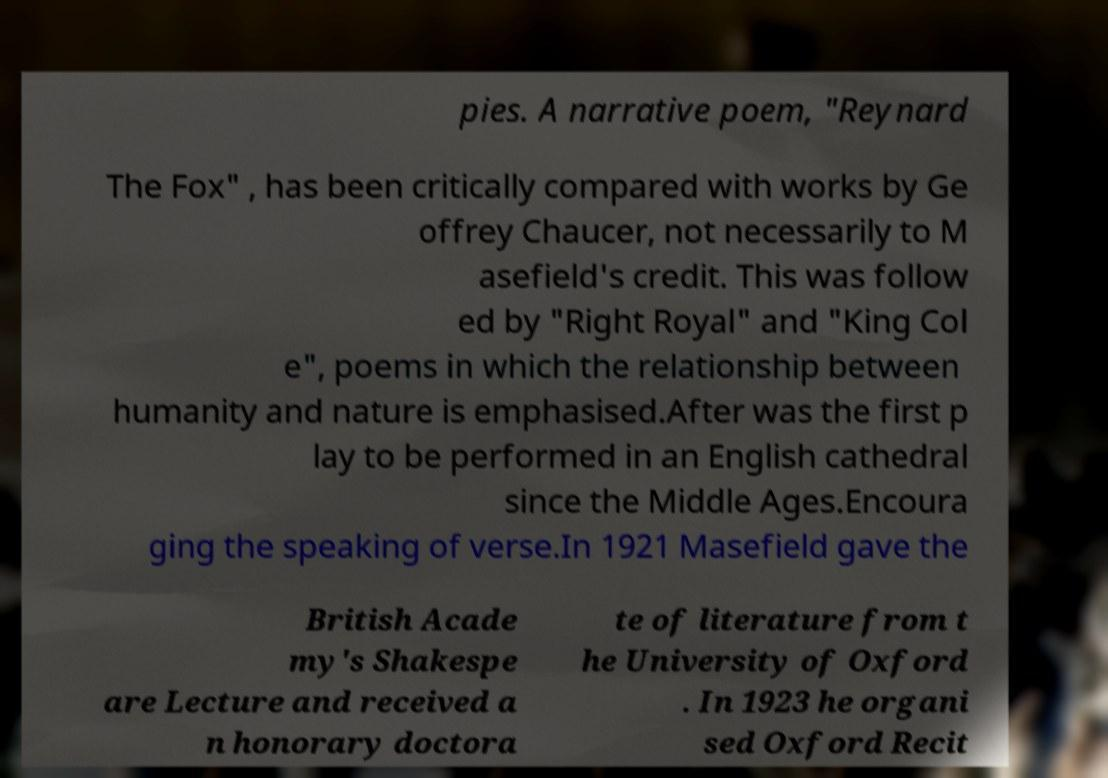Can you read and provide the text displayed in the image?This photo seems to have some interesting text. Can you extract and type it out for me? pies. A narrative poem, "Reynard The Fox" , has been critically compared with works by Ge offrey Chaucer, not necessarily to M asefield's credit. This was follow ed by "Right Royal" and "King Col e", poems in which the relationship between humanity and nature is emphasised.After was the first p lay to be performed in an English cathedral since the Middle Ages.Encoura ging the speaking of verse.In 1921 Masefield gave the British Acade my's Shakespe are Lecture and received a n honorary doctora te of literature from t he University of Oxford . In 1923 he organi sed Oxford Recit 